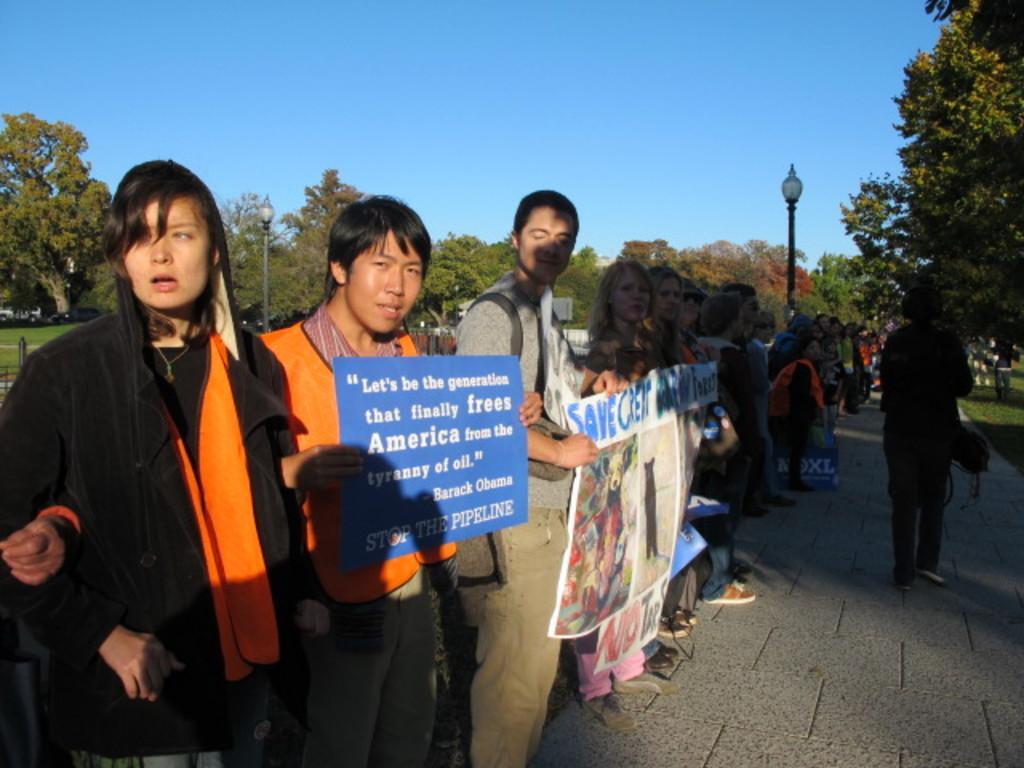How would you summarize this image in a sentence or two? In this picture, there are people standing in the row with placards and charts. Towards the left, there is a woman wearing a black blazer. Beside her, there is a man in an orange t shirt. Towards the right, there is a person. In the background there are trees, poles and a sky. 